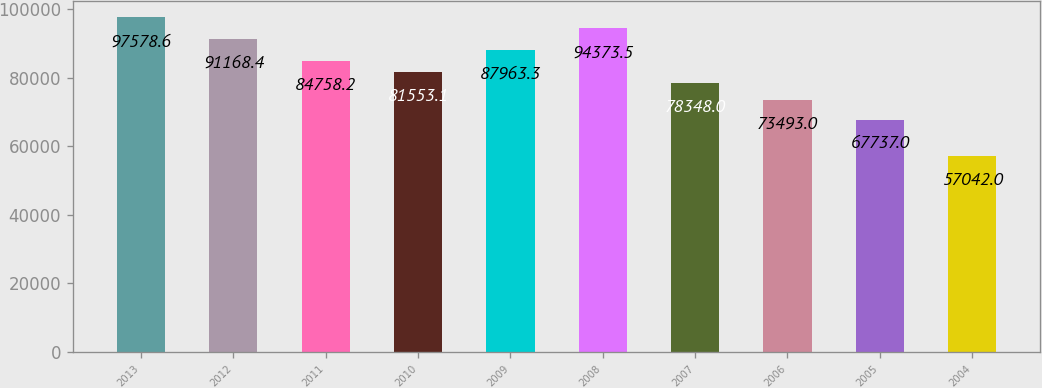<chart> <loc_0><loc_0><loc_500><loc_500><bar_chart><fcel>2013<fcel>2012<fcel>2011<fcel>2010<fcel>2009<fcel>2008<fcel>2007<fcel>2006<fcel>2005<fcel>2004<nl><fcel>97578.6<fcel>91168.4<fcel>84758.2<fcel>81553.1<fcel>87963.3<fcel>94373.5<fcel>78348<fcel>73493<fcel>67737<fcel>57042<nl></chart> 